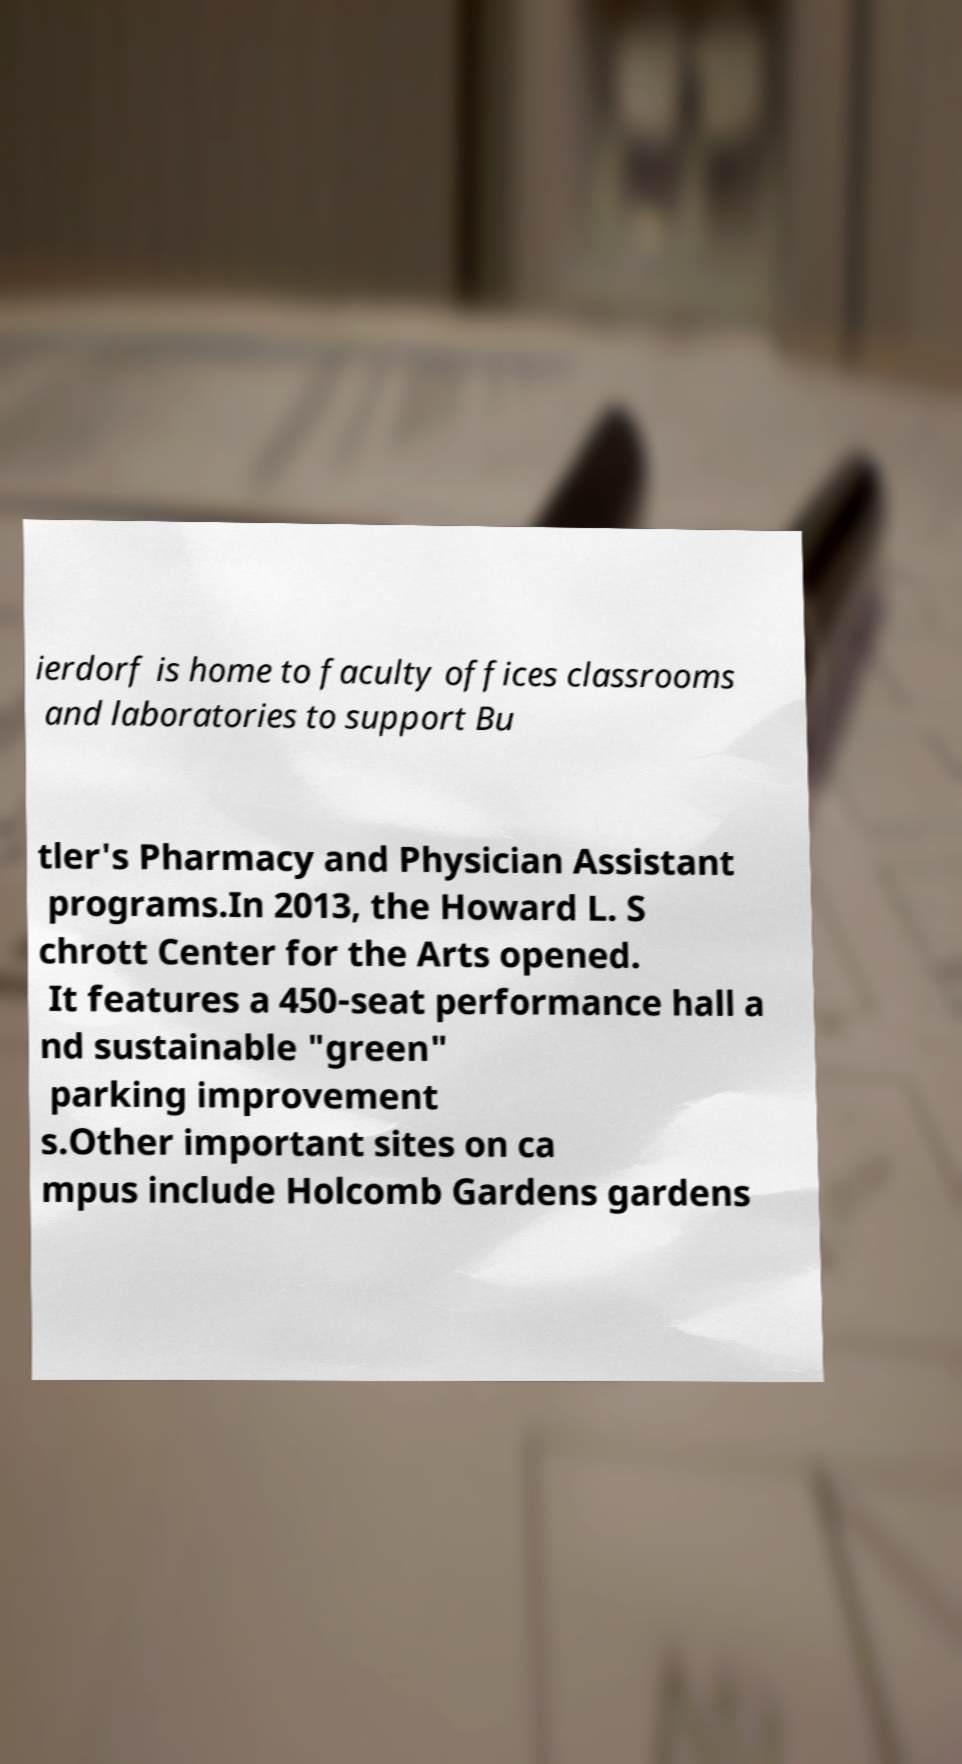There's text embedded in this image that I need extracted. Can you transcribe it verbatim? ierdorf is home to faculty offices classrooms and laboratories to support Bu tler's Pharmacy and Physician Assistant programs.In 2013, the Howard L. S chrott Center for the Arts opened. It features a 450-seat performance hall a nd sustainable "green" parking improvement s.Other important sites on ca mpus include Holcomb Gardens gardens 